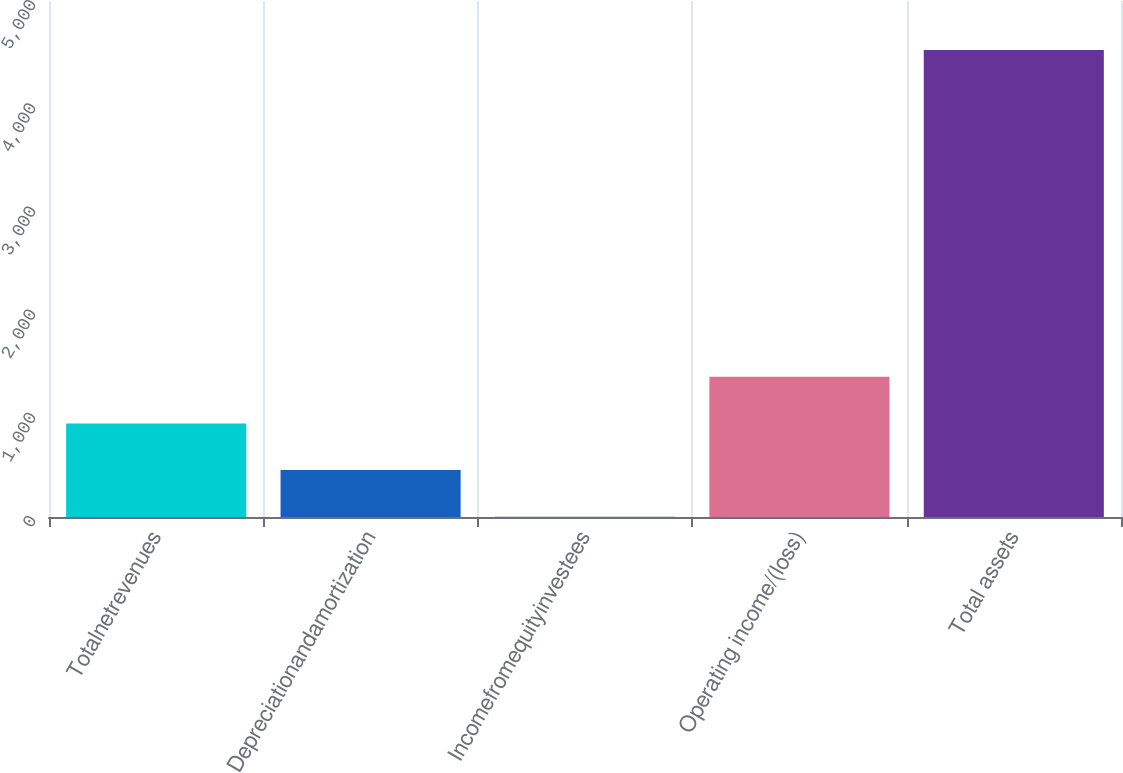<chart> <loc_0><loc_0><loc_500><loc_500><bar_chart><fcel>Totalnetrevenues<fcel>Depreciationandamortization<fcel>Incomefromequityinvestees<fcel>Operating income/(loss)<fcel>Total assets<nl><fcel>907.04<fcel>454.72<fcel>2.4<fcel>1359.36<fcel>4525.6<nl></chart> 